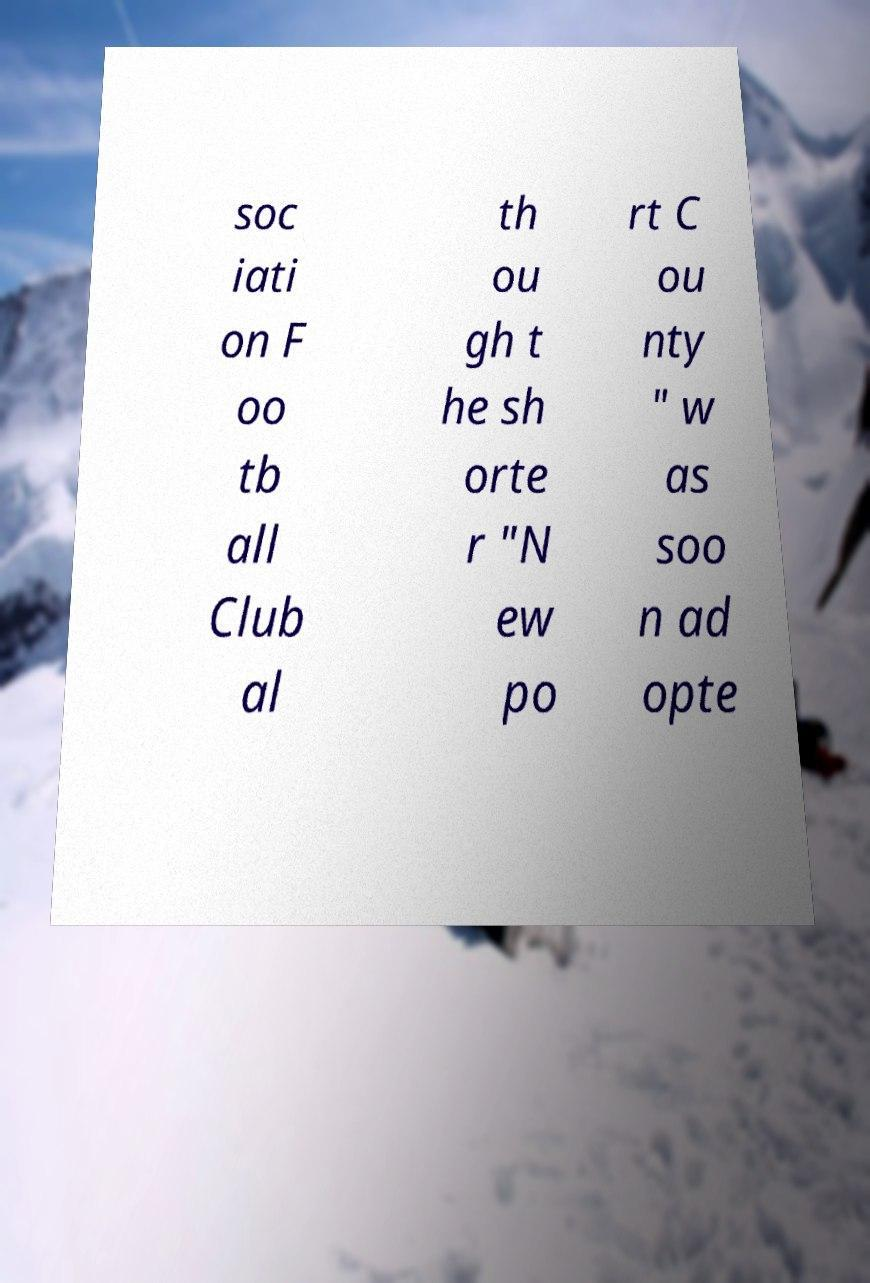Can you accurately transcribe the text from the provided image for me? soc iati on F oo tb all Club al th ou gh t he sh orte r "N ew po rt C ou nty " w as soo n ad opte 